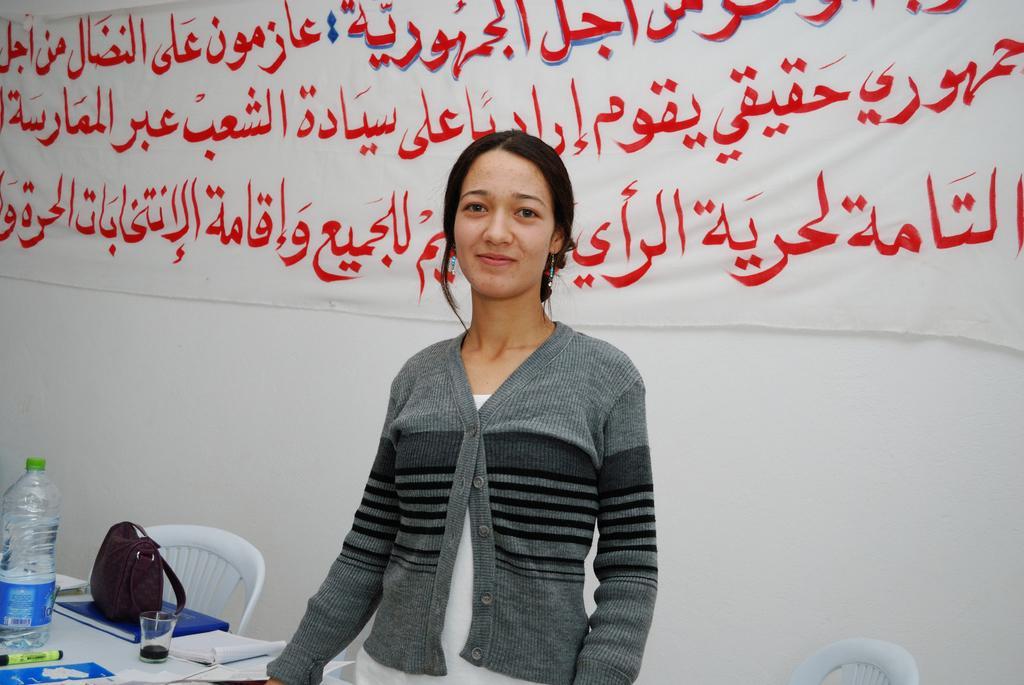Describe this image in one or two sentences. In this image in front there is a person standing in front of the table. On top of the table there is a water bottle, glass, book, marker. Beside her there are two chairs. Behind her there is a banner attached to the wall. 